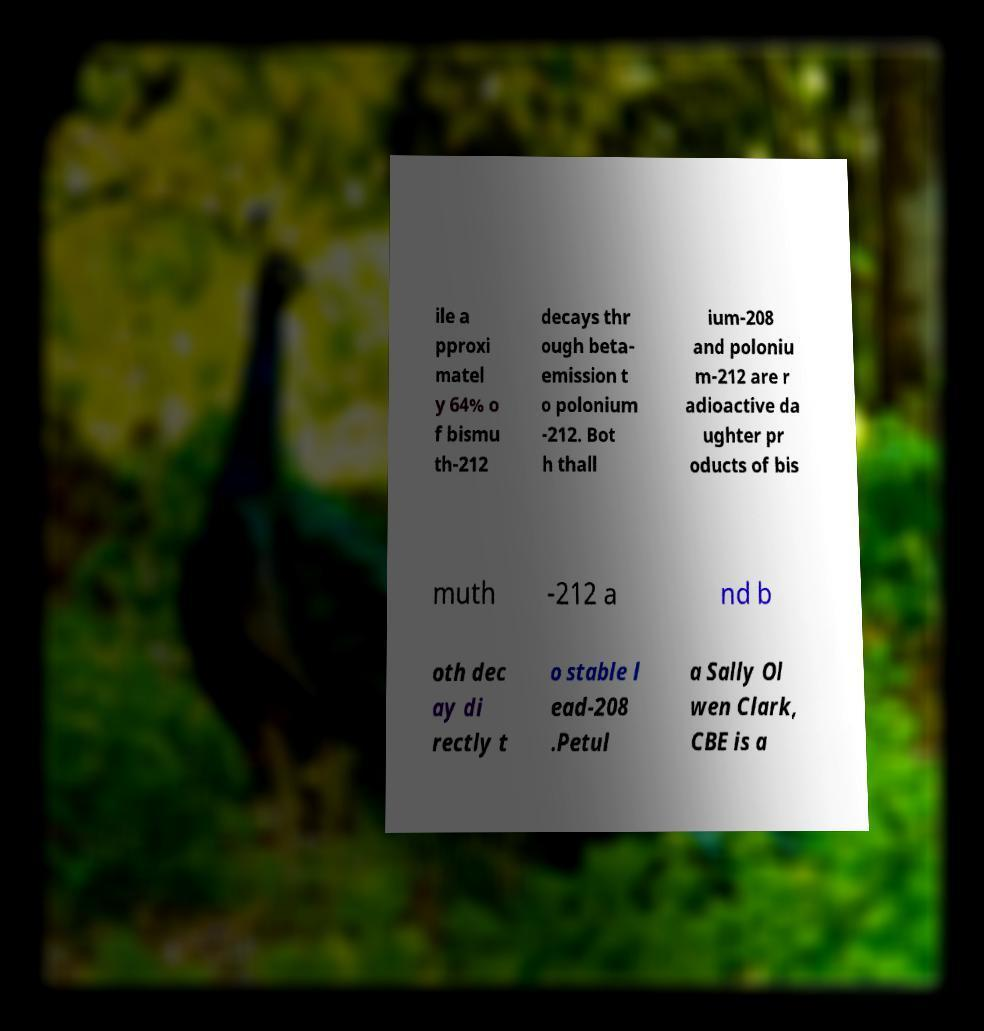Please read and relay the text visible in this image. What does it say? ile a pproxi matel y 64% o f bismu th-212 decays thr ough beta- emission t o polonium -212. Bot h thall ium-208 and poloniu m-212 are r adioactive da ughter pr oducts of bis muth -212 a nd b oth dec ay di rectly t o stable l ead-208 .Petul a Sally Ol wen Clark, CBE is a 